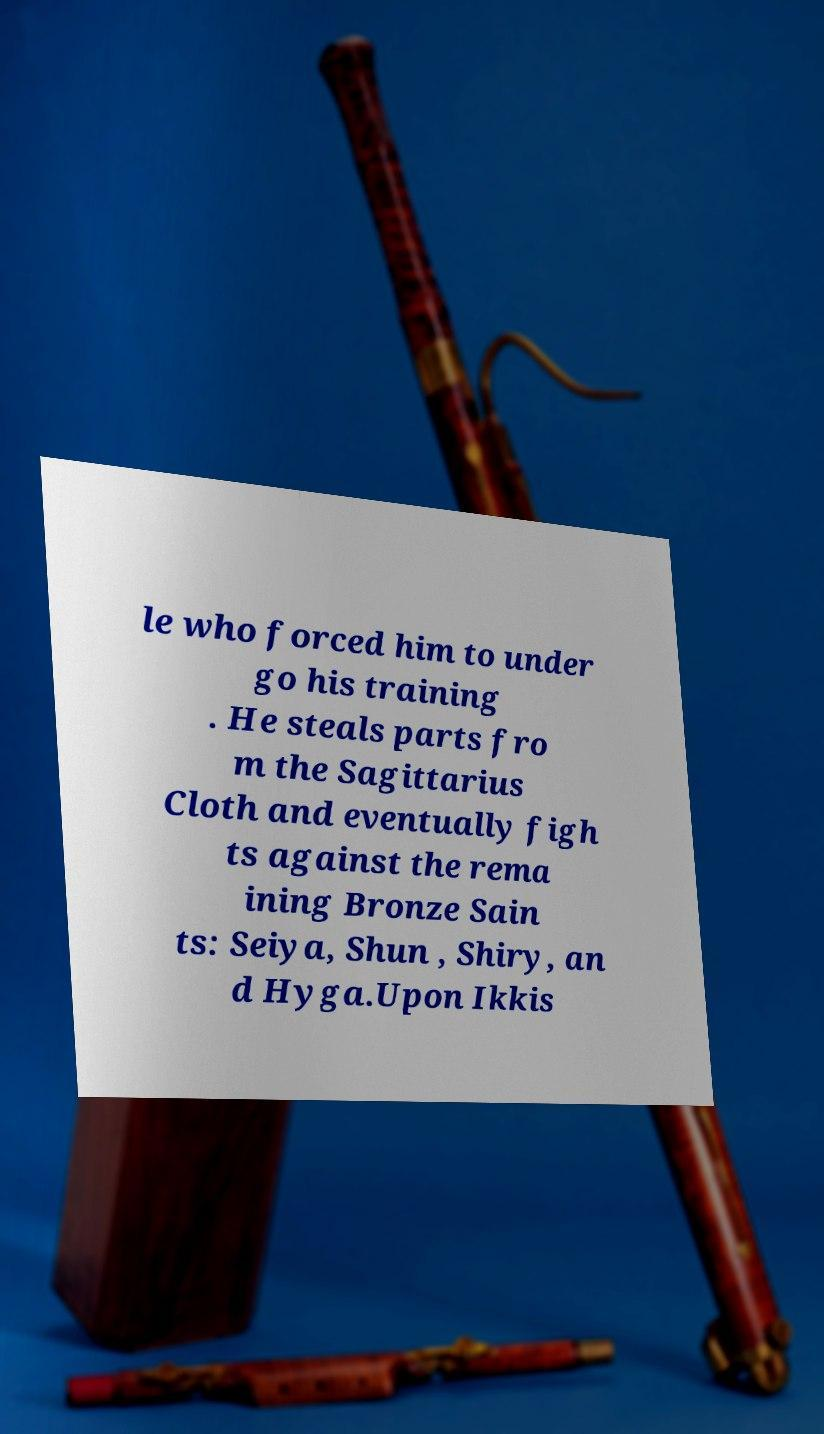Could you extract and type out the text from this image? le who forced him to under go his training . He steals parts fro m the Sagittarius Cloth and eventually figh ts against the rema ining Bronze Sain ts: Seiya, Shun , Shiry, an d Hyga.Upon Ikkis 